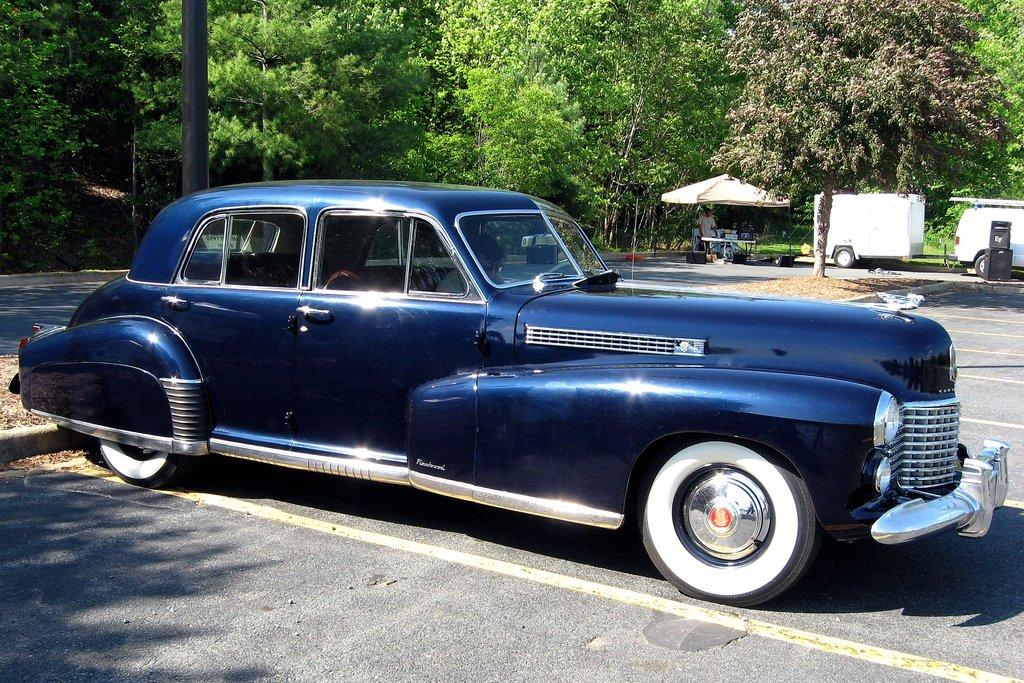What color is the vehicle in the image? The vehicle in the image is blue in color. What can be seen on the ground in the image? There is a road in the image. What object is standing upright in the image? There is a pole in the image. What type of shelter is present in the image? There is a tent in the image. What type of vegetation is visible in the image? There are trees in the image. What is the person in the image wearing? There is a person wearing clothes in the image. Can you see any cobwebs in the image? There is no mention of cobwebs in the image, so it cannot be determined if any are present. 